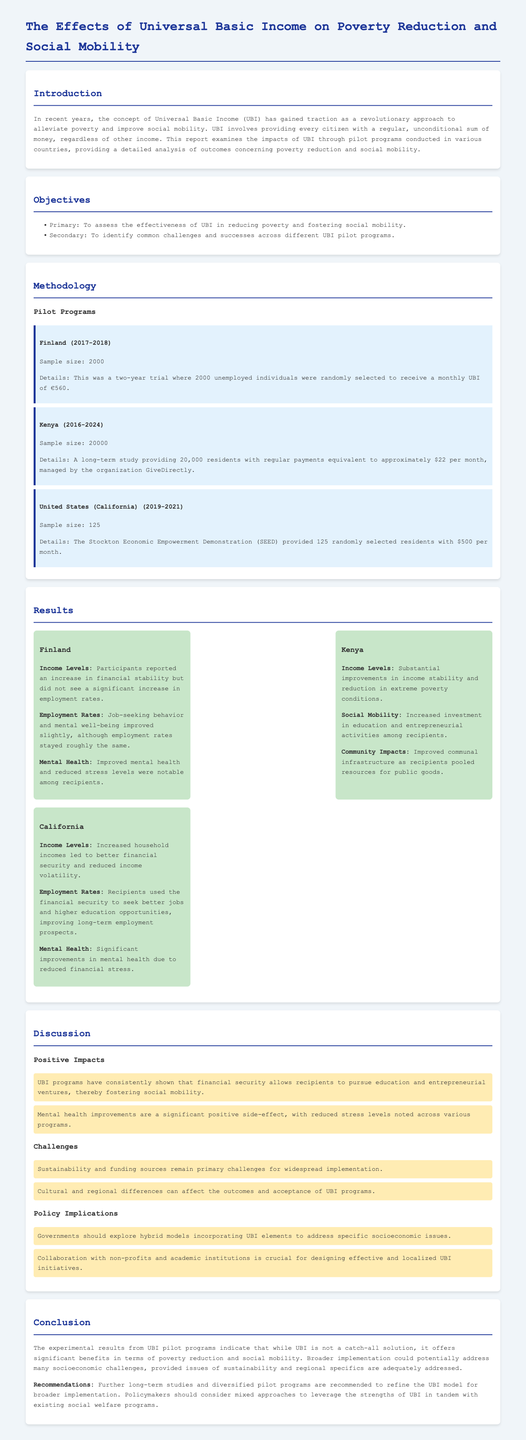What was the sample size for the Finland pilot program? The Finland pilot program had a sample size of 2000 participants.
Answer: 2000 What amount did recipients in California receive monthly? In California, participants received $500 per month as part of the SEED program.
Answer: $500 What was a notable improvement for participants in the Kenya program? Participants in Kenya saw increased investment in education and entrepreneurial activities.
Answer: Education and entrepreneurial activities What is one main challenge identified for UBI programs? Sustainability and funding sources are primary challenges for widespread implementation of UBI.
Answer: Sustainability and funding sources What year did the UBI pilot program in California start? The pilot program in California started in 2019.
Answer: 2019 How many months did the Finland UBI program last? The Finland UBI program lasted for two years, which is 24 months.
Answer: 24 months What were the mental health outcomes in California’s UBI program? Significant improvements in mental health were noted due to reduced financial stress.
Answer: Significant improvements What is suggested for future UBI studies? The report recommends further long-term studies and diversified pilot programs.
Answer: Long-term studies and diversified pilot programs What is the primary objective of the UBI analysis in this report? The primary objective is to assess effectiveness in reducing poverty and fostering social mobility.
Answer: Reduce poverty and foster social mobility 